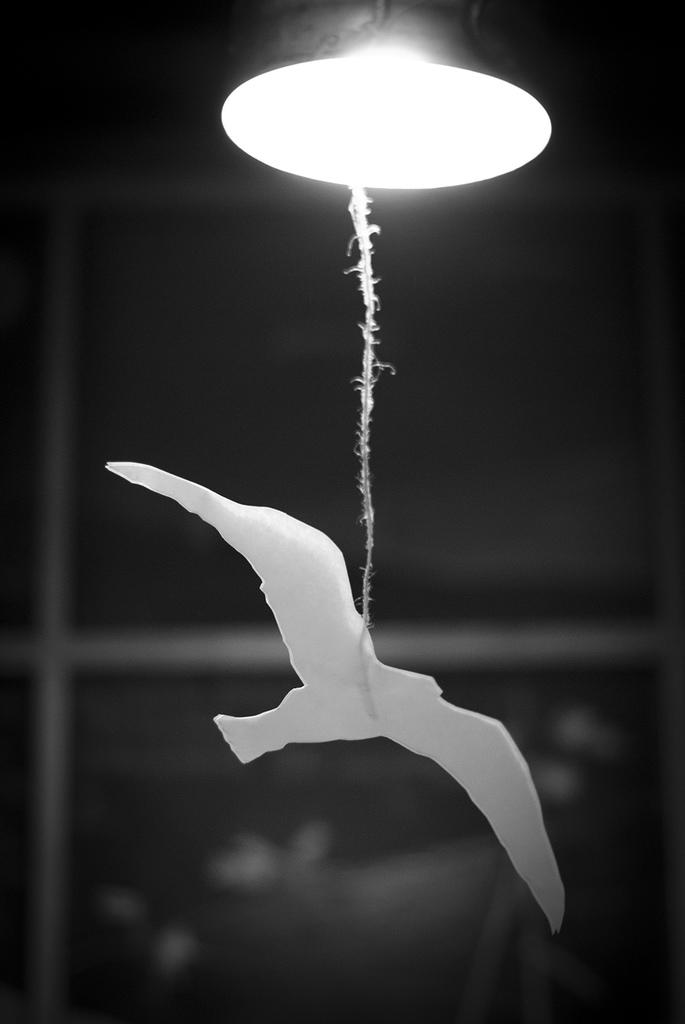What object can be seen in the image? There is a lamp in the image. What is unique about the lamp? There is a bird structure attached to the lamp. How is the bird structure connected to the lamp? The bird structure is attached to the lamp via a rope. What can be observed about the background of the image? The background of the image is black. What type of fog can be seen surrounding the lamp in the image? There is no fog present in the image; the background is black. What nation is represented by the bird structure on the lamp? The image does not provide information about the nation represented by the bird structure. 